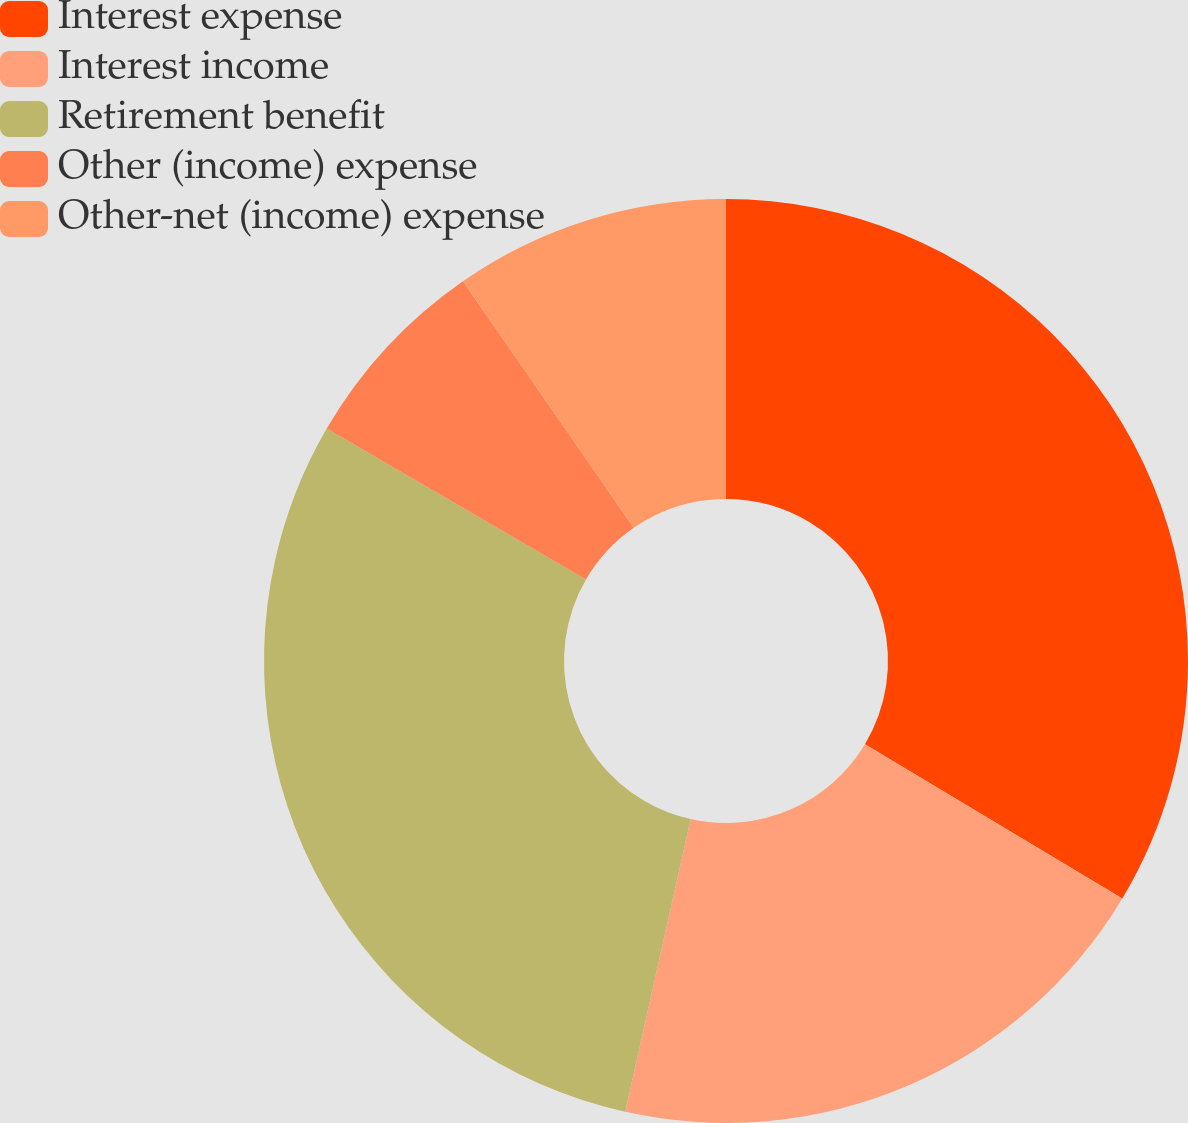Convert chart. <chart><loc_0><loc_0><loc_500><loc_500><pie_chart><fcel>Interest expense<fcel>Interest income<fcel>Retirement benefit<fcel>Other (income) expense<fcel>Other-net (income) expense<nl><fcel>33.59%<fcel>19.91%<fcel>29.89%<fcel>6.97%<fcel>9.64%<nl></chart> 